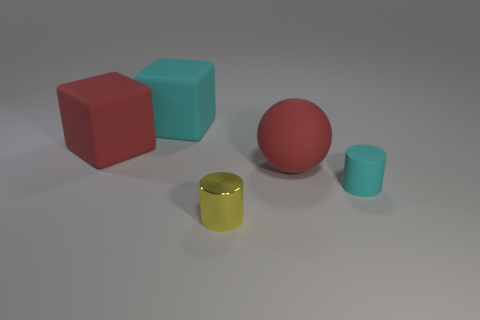How many other objects are there of the same material as the tiny cyan thing?
Offer a terse response. 3. Are there any other things that have the same size as the sphere?
Offer a terse response. Yes. Is the number of yellow matte objects greater than the number of rubber blocks?
Your answer should be very brief. No. There is a red rubber thing that is on the left side of the cyan matte thing that is left of the cyan matte object on the right side of the tiny metal object; how big is it?
Offer a terse response. Large. There is a cyan cylinder; is its size the same as the block in front of the cyan cube?
Give a very brief answer. No. Are there fewer big cyan objects that are in front of the large cyan rubber block than large purple matte objects?
Your answer should be very brief. No. How many cylinders have the same color as the small shiny object?
Your response must be concise. 0. Is the number of tiny yellow metallic objects less than the number of green metal blocks?
Make the answer very short. No. Is the material of the small yellow thing the same as the tiny cyan object?
Your answer should be very brief. No. How many other objects are there of the same size as the sphere?
Ensure brevity in your answer.  2. 